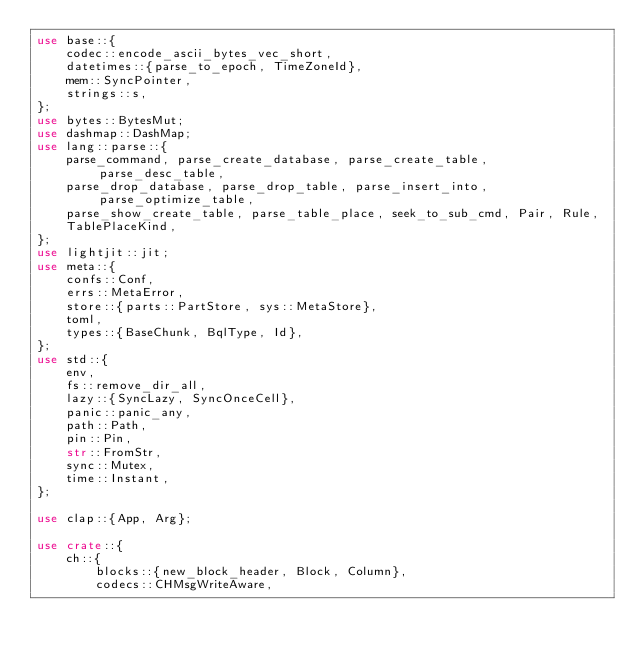Convert code to text. <code><loc_0><loc_0><loc_500><loc_500><_Rust_>use base::{
    codec::encode_ascii_bytes_vec_short,
    datetimes::{parse_to_epoch, TimeZoneId},
    mem::SyncPointer,
    strings::s,
};
use bytes::BytesMut;
use dashmap::DashMap;
use lang::parse::{
    parse_command, parse_create_database, parse_create_table, parse_desc_table,
    parse_drop_database, parse_drop_table, parse_insert_into, parse_optimize_table,
    parse_show_create_table, parse_table_place, seek_to_sub_cmd, Pair, Rule,
    TablePlaceKind,
};
use lightjit::jit;
use meta::{
    confs::Conf,
    errs::MetaError,
    store::{parts::PartStore, sys::MetaStore},
    toml,
    types::{BaseChunk, BqlType, Id},
};
use std::{
    env,
    fs::remove_dir_all,
    lazy::{SyncLazy, SyncOnceCell},
    panic::panic_any,
    path::Path,
    pin::Pin,
    str::FromStr,
    sync::Mutex,
    time::Instant,
};

use clap::{App, Arg};

use crate::{
    ch::{
        blocks::{new_block_header, Block, Column},
        codecs::CHMsgWriteAware,</code> 